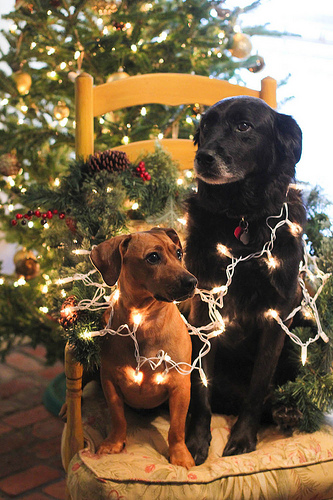<image>
Can you confirm if the dog is under the dog? No. The dog is not positioned under the dog. The vertical relationship between these objects is different. 